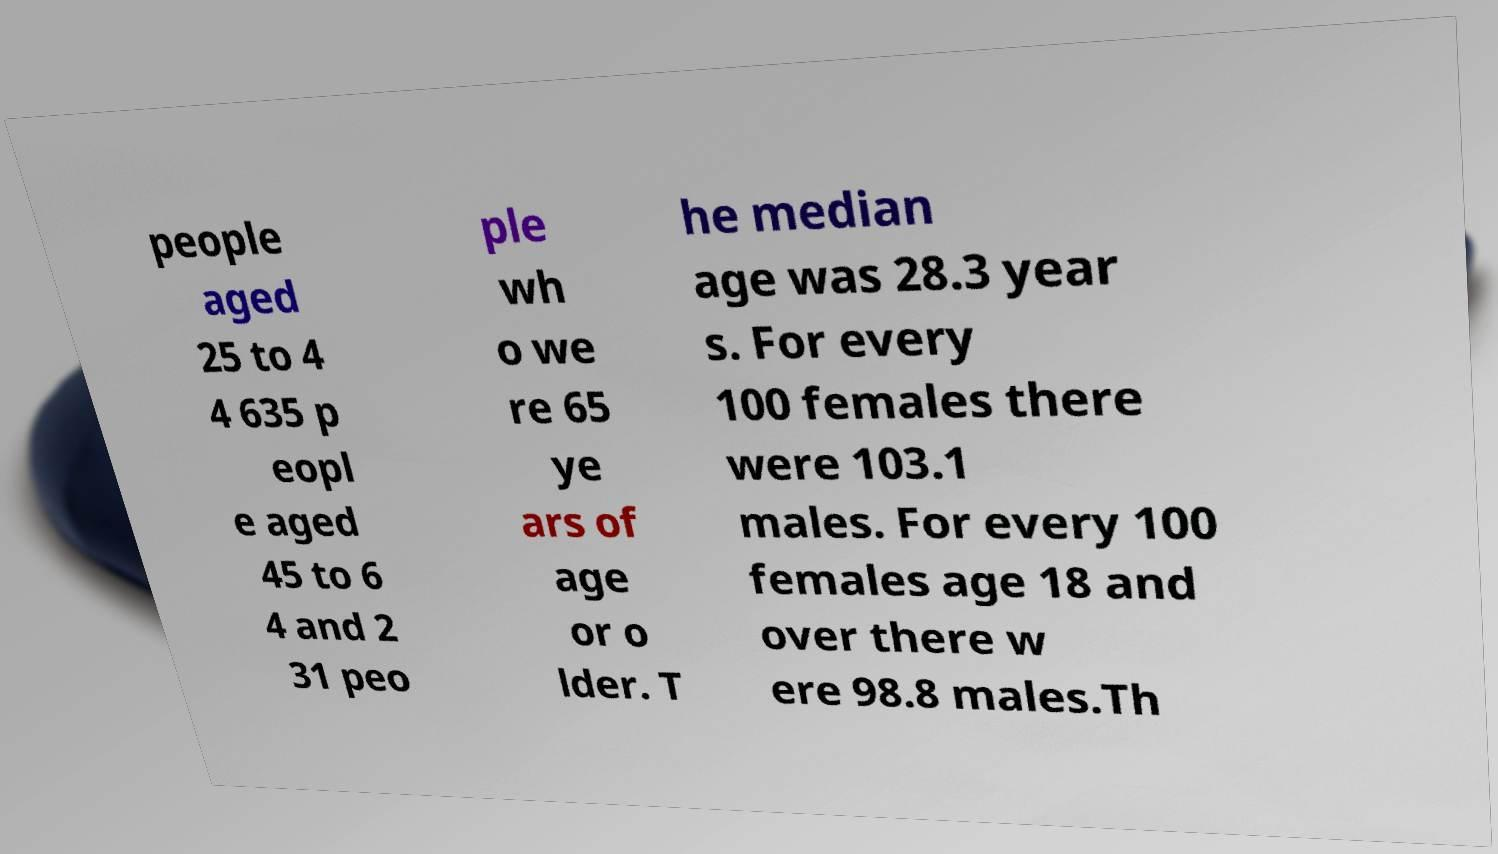There's text embedded in this image that I need extracted. Can you transcribe it verbatim? people aged 25 to 4 4 635 p eopl e aged 45 to 6 4 and 2 31 peo ple wh o we re 65 ye ars of age or o lder. T he median age was 28.3 year s. For every 100 females there were 103.1 males. For every 100 females age 18 and over there w ere 98.8 males.Th 